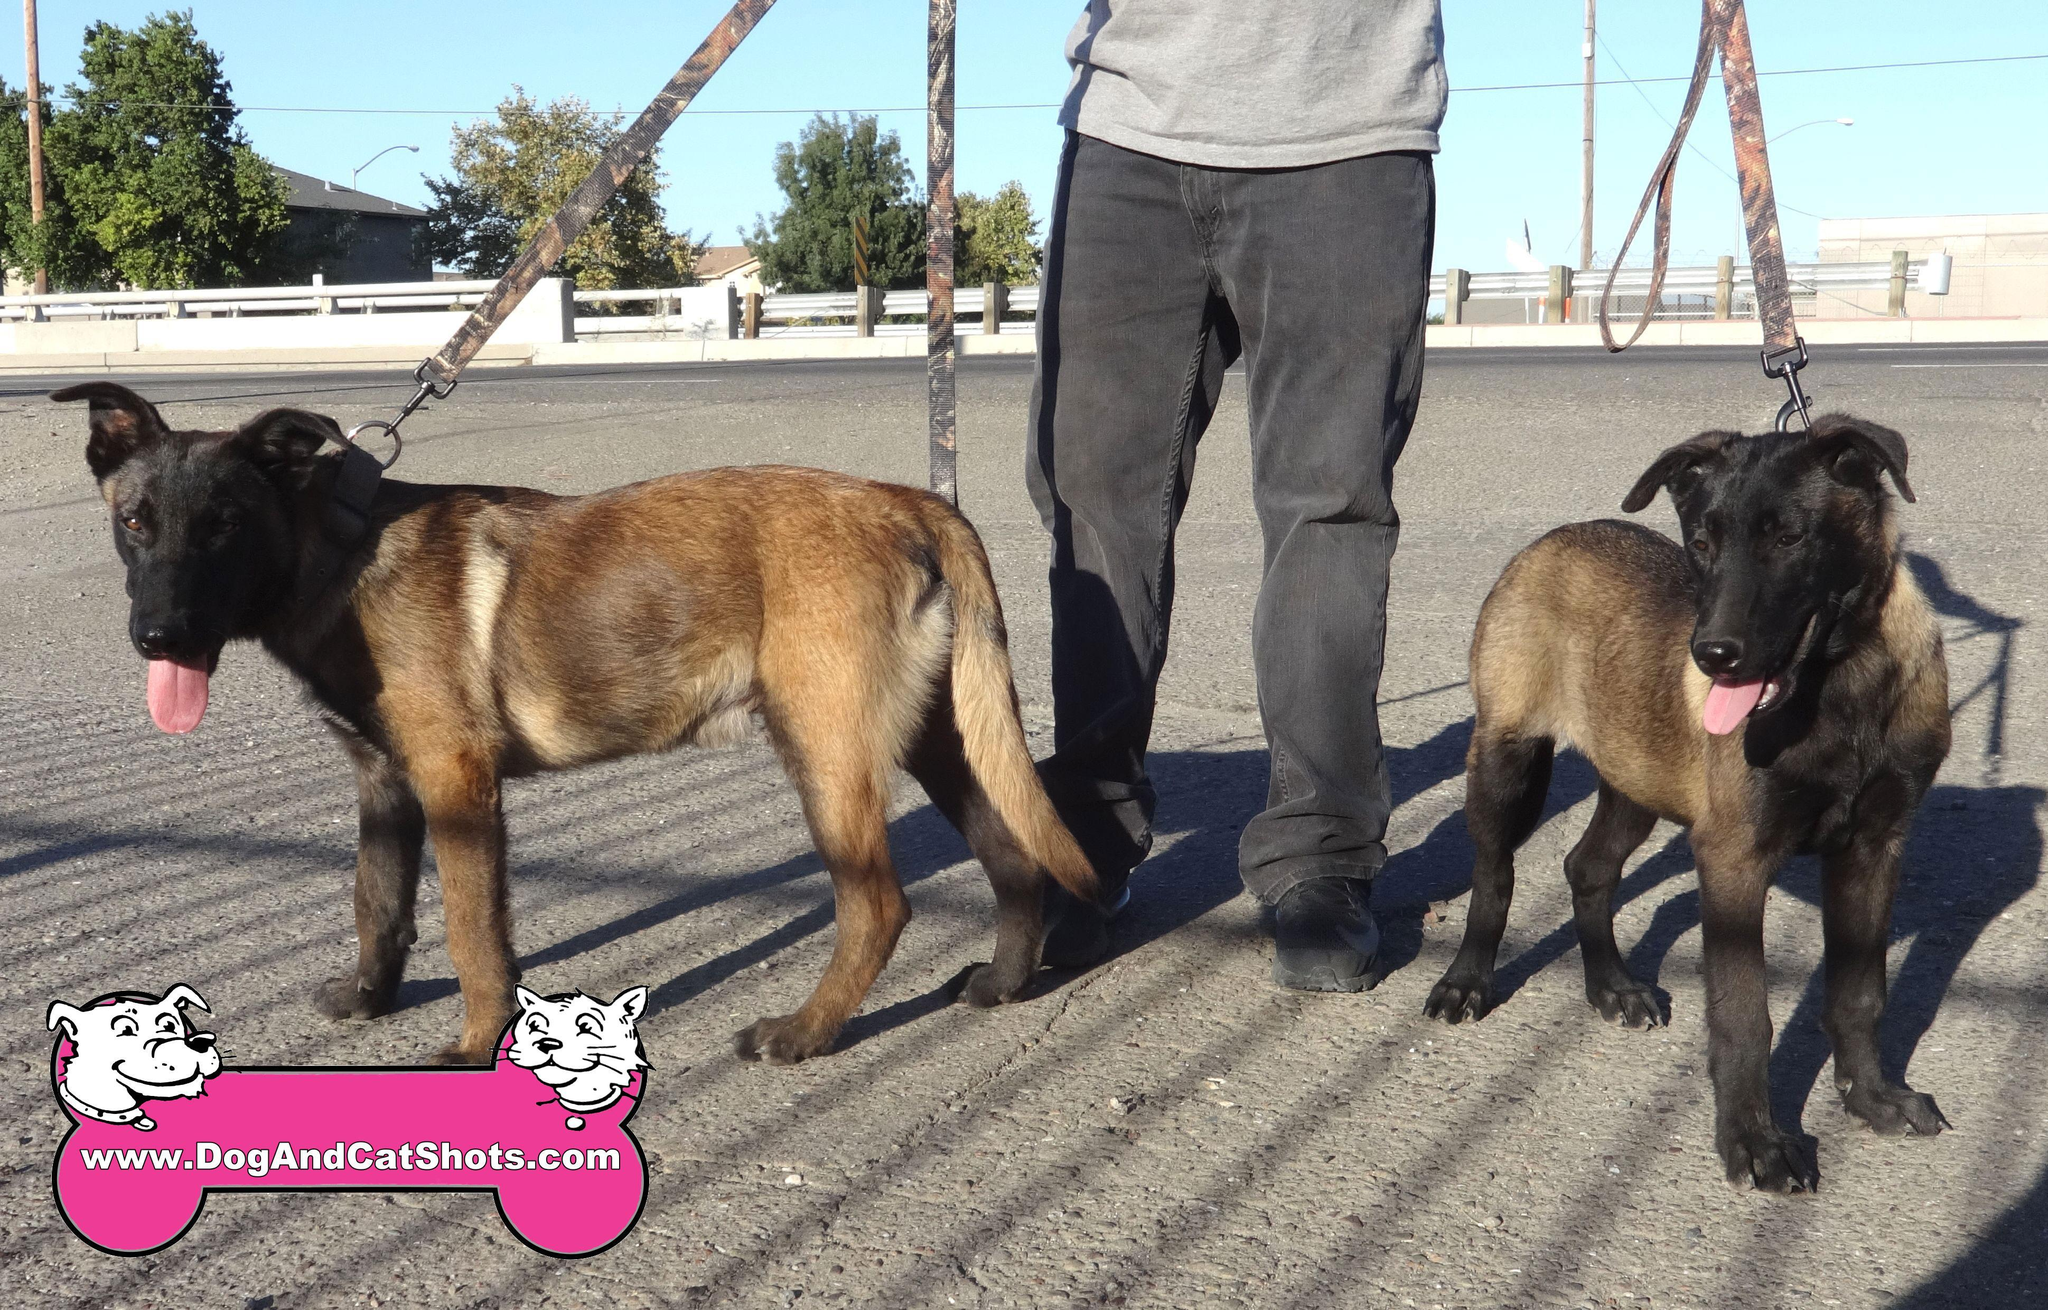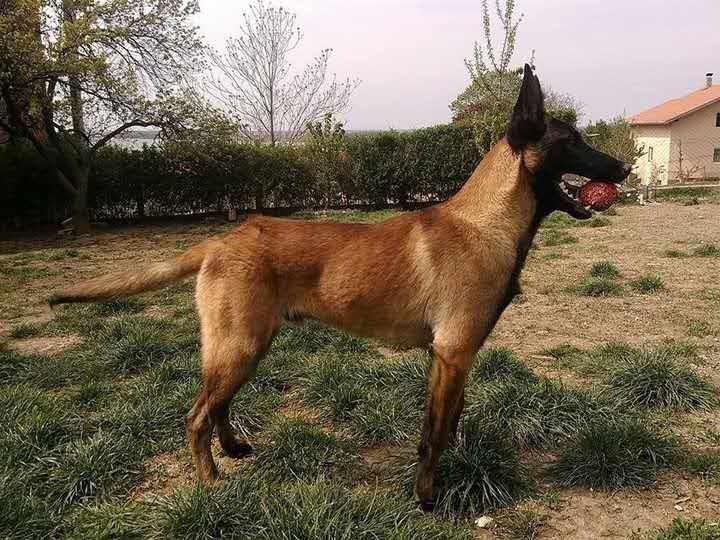The first image is the image on the left, the second image is the image on the right. For the images shown, is this caption "At least two dogs are lying down on the ground." true? Answer yes or no. No. The first image is the image on the left, the second image is the image on the right. Considering the images on both sides, is "There are 2 or more German Shepard's laying down on grass." valid? Answer yes or no. No. 